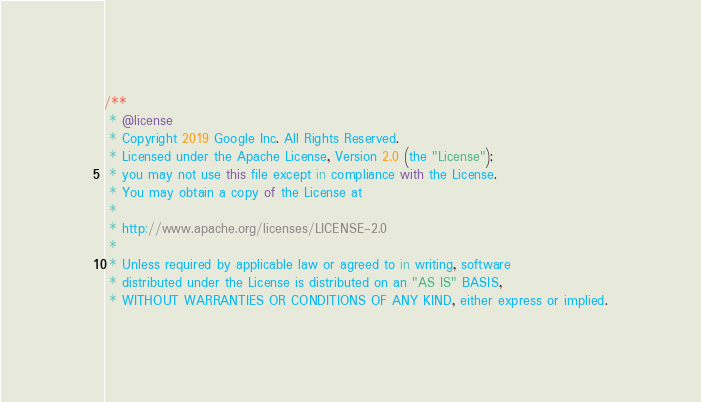Convert code to text. <code><loc_0><loc_0><loc_500><loc_500><_TypeScript_>/**
 * @license
 * Copyright 2019 Google Inc. All Rights Reserved.
 * Licensed under the Apache License, Version 2.0 (the "License");
 * you may not use this file except in compliance with the License.
 * You may obtain a copy of the License at
 *
 * http://www.apache.org/licenses/LICENSE-2.0
 *
 * Unless required by applicable law or agreed to in writing, software
 * distributed under the License is distributed on an "AS IS" BASIS,
 * WITHOUT WARRANTIES OR CONDITIONS OF ANY KIND, either express or implied.</code> 